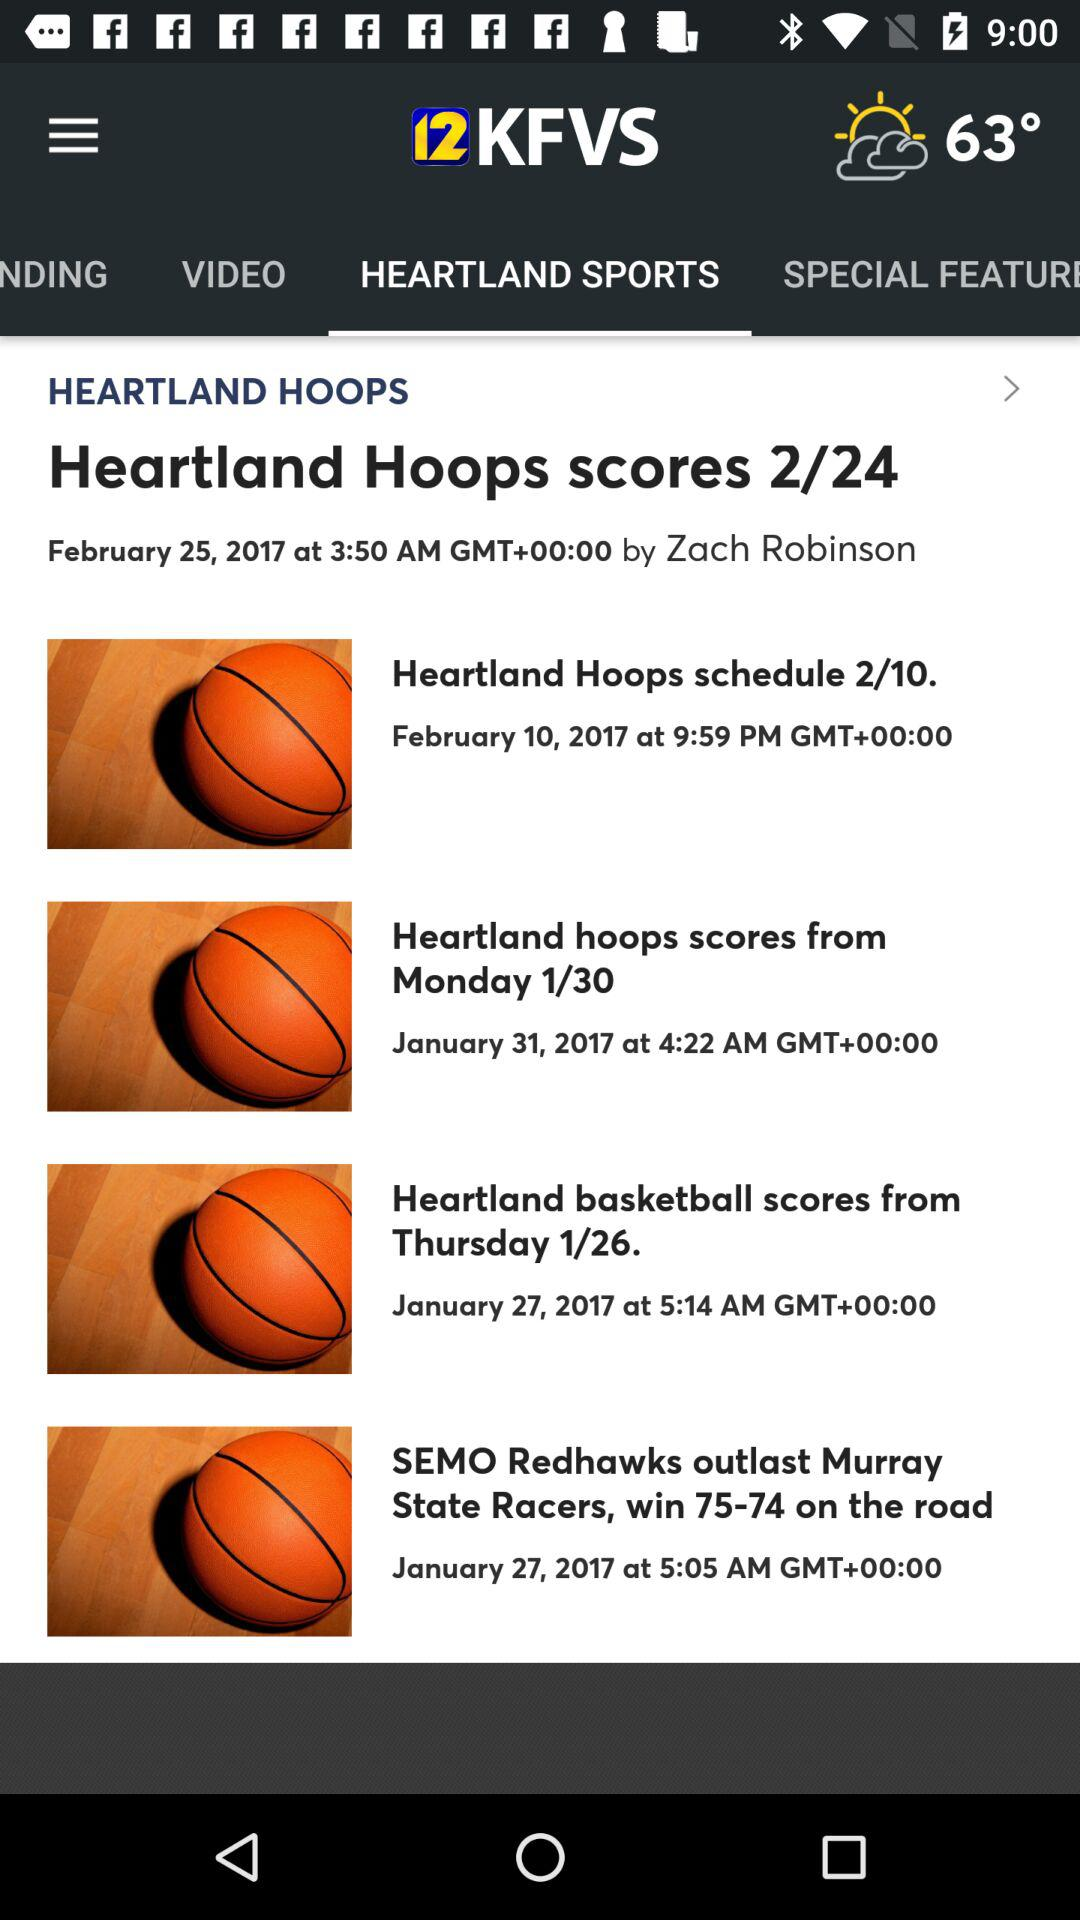What is the application name? The application name is "12KFVS". 